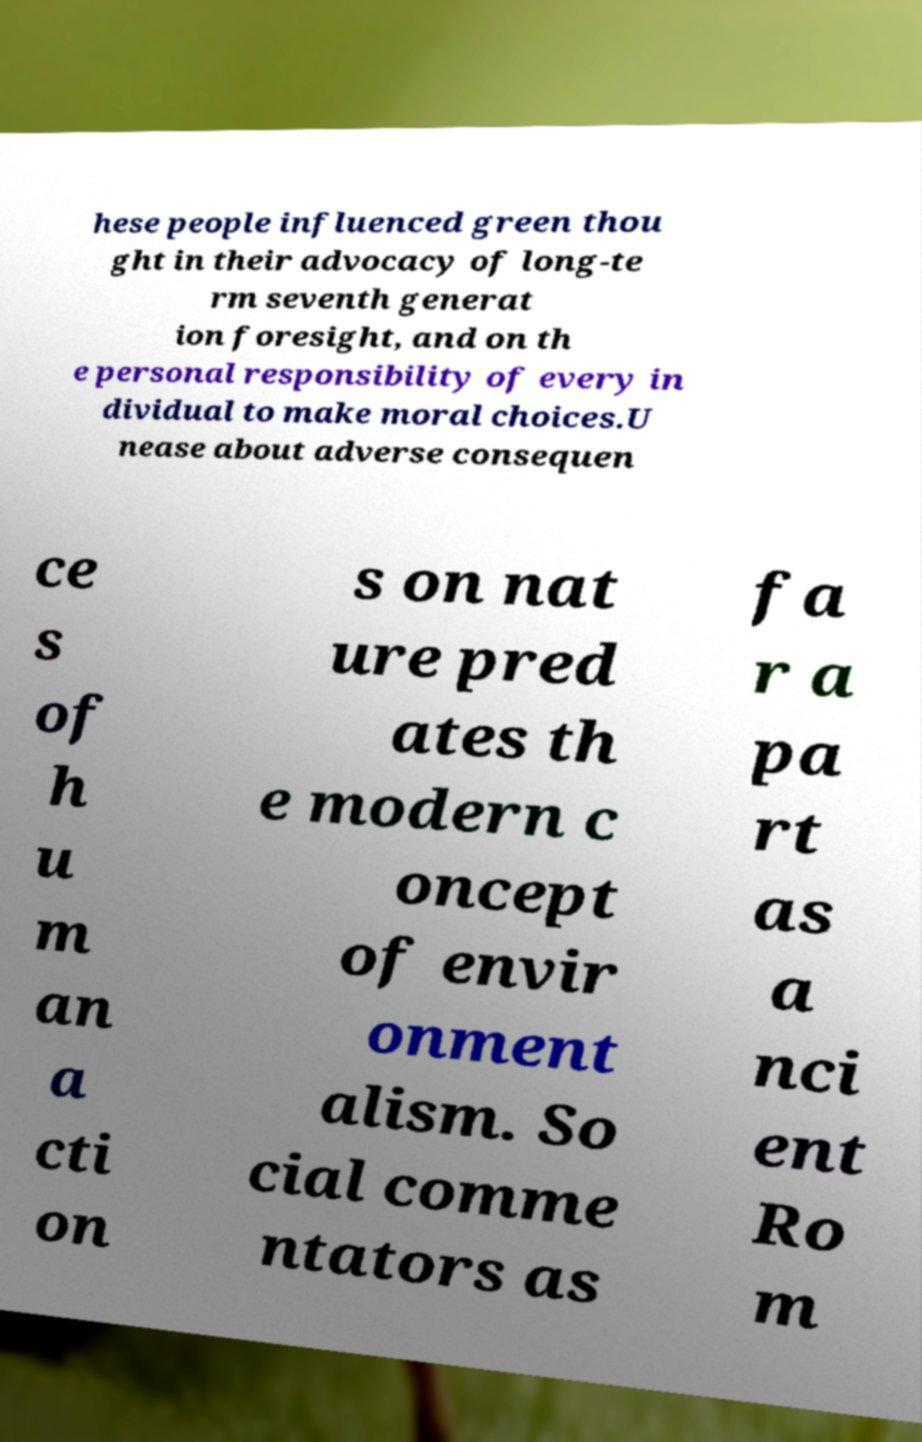There's text embedded in this image that I need extracted. Can you transcribe it verbatim? hese people influenced green thou ght in their advocacy of long-te rm seventh generat ion foresight, and on th e personal responsibility of every in dividual to make moral choices.U nease about adverse consequen ce s of h u m an a cti on s on nat ure pred ates th e modern c oncept of envir onment alism. So cial comme ntators as fa r a pa rt as a nci ent Ro m 